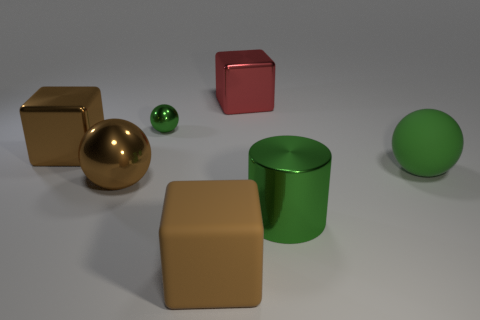Is the number of large brown rubber cubes on the left side of the brown metal block greater than the number of brown metallic cylinders?
Ensure brevity in your answer.  No. The metallic cube that is on the left side of the red object is what color?
Keep it short and to the point. Brown. Is the size of the brown matte cube the same as the brown sphere?
Your answer should be very brief. Yes. What is the size of the brown shiny cube?
Ensure brevity in your answer.  Large. There is a big matte thing that is the same color as the tiny metal ball; what shape is it?
Your answer should be compact. Sphere. Are there more small green things than large purple cylinders?
Your response must be concise. Yes. There is a big rubber object on the right side of the cube that is in front of the big block that is to the left of the tiny green metallic object; what is its color?
Your answer should be compact. Green. There is a big green thing in front of the brown metal ball; is it the same shape as the tiny shiny object?
Offer a terse response. No. There is a cylinder that is the same size as the rubber sphere; what is its color?
Offer a terse response. Green. How many spheres are there?
Your response must be concise. 3. 